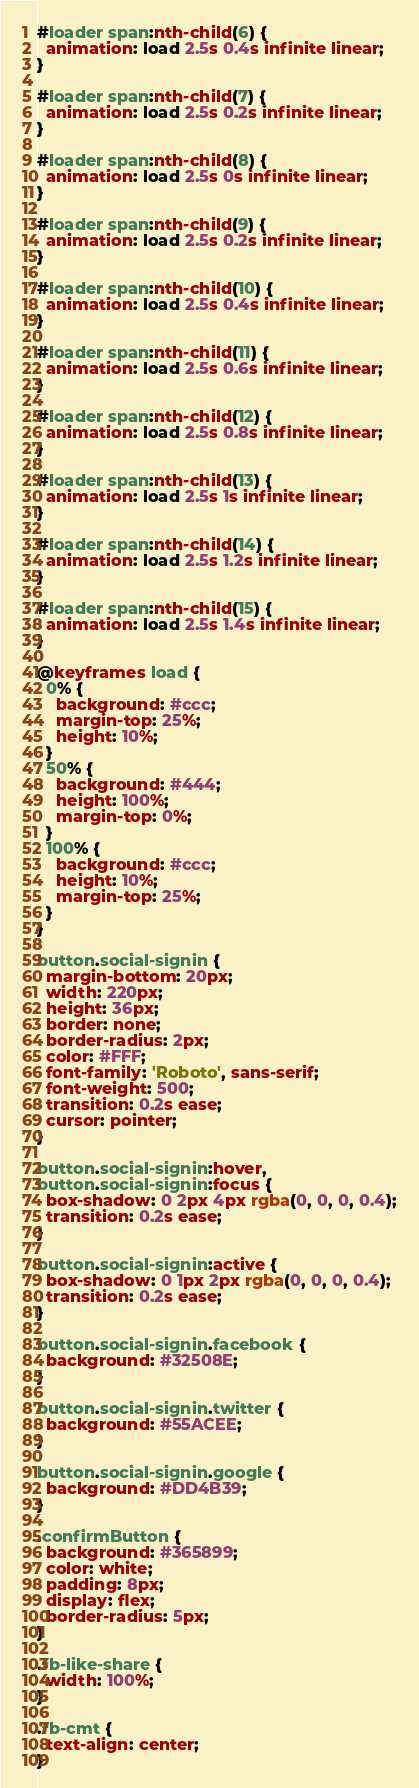Convert code to text. <code><loc_0><loc_0><loc_500><loc_500><_CSS_>#loader span:nth-child(6) {
  animation: load 2.5s 0.4s infinite linear;
}

#loader span:nth-child(7) {
  animation: load 2.5s 0.2s infinite linear;
}

#loader span:nth-child(8) {
  animation: load 2.5s 0s infinite linear;
}

#loader span:nth-child(9) {
  animation: load 2.5s 0.2s infinite linear;
}

#loader span:nth-child(10) {
  animation: load 2.5s 0.4s infinite linear;
}

#loader span:nth-child(11) {
  animation: load 2.5s 0.6s infinite linear;
}

#loader span:nth-child(12) {
  animation: load 2.5s 0.8s infinite linear;
}

#loader span:nth-child(13) {
  animation: load 2.5s 1s infinite linear;
}

#loader span:nth-child(14) {
  animation: load 2.5s 1.2s infinite linear;
}

#loader span:nth-child(15) {
  animation: load 2.5s 1.4s infinite linear;
}

@keyframes load {
  0% {
    background: #ccc;
    margin-top: 25%;
    height: 10%;
  }
  50% {
    background: #444;
    height: 100%;
    margin-top: 0%;
  }
  100% {
    background: #ccc;
    height: 10%;
    margin-top: 25%;
  }
}

button.social-signin {
  margin-bottom: 20px;
  width: 220px;
  height: 36px;
  border: none;
  border-radius: 2px;
  color: #FFF;
  font-family: 'Roboto', sans-serif;
  font-weight: 500;
  transition: 0.2s ease;
  cursor: pointer;
}

button.social-signin:hover,
button.social-signin:focus {
  box-shadow: 0 2px 4px rgba(0, 0, 0, 0.4);
  transition: 0.2s ease;
}

button.social-signin:active {
  box-shadow: 0 1px 2px rgba(0, 0, 0, 0.4);
  transition: 0.2s ease;
}

button.social-signin.facebook {
  background: #32508E;
}

button.social-signin.twitter {
  background: #55ACEE;
}

button.social-signin.google {
  background: #DD4B39;
}

.confirmButton {
  background: #365899;
  color: white;
  padding: 8px;
  display: flex;
  border-radius: 5px;
}

.fb-like-share {
  width: 100%;
}

.fb-cmt {
  text-align: center;
}</code> 